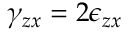<formula> <loc_0><loc_0><loc_500><loc_500>\gamma _ { z x } = 2 \epsilon _ { z x }</formula> 